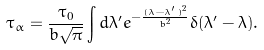Convert formula to latex. <formula><loc_0><loc_0><loc_500><loc_500>\tau _ { \alpha } = \frac { \tau _ { 0 } } { b \sqrt { \pi } } \int d \lambda ^ { \prime } e ^ { - \frac { ( \lambda - \lambda ^ { \prime } ) ^ { 2 } } { b ^ { 2 } } } \delta ( \lambda ^ { \prime } - \lambda ) .</formula> 